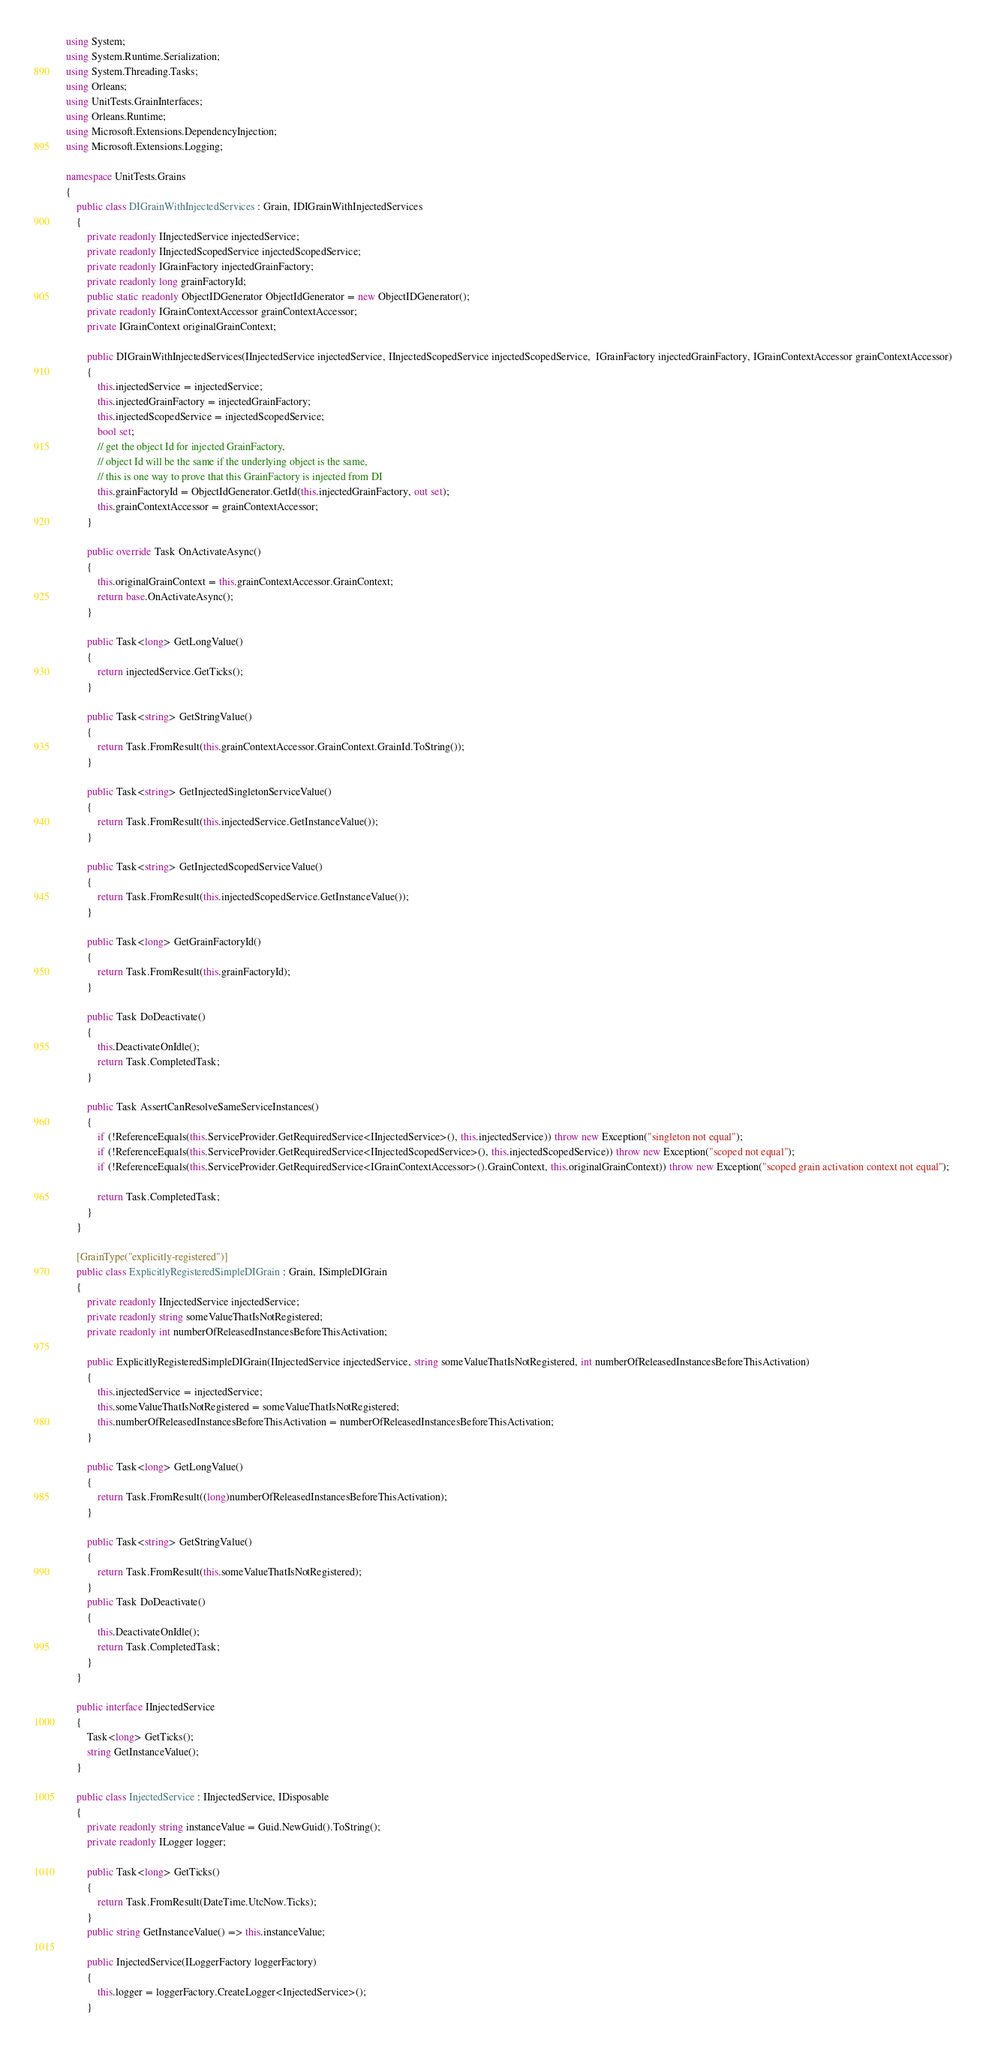<code> <loc_0><loc_0><loc_500><loc_500><_C#_>using System;
using System.Runtime.Serialization;
using System.Threading.Tasks;
using Orleans;
using UnitTests.GrainInterfaces;
using Orleans.Runtime;
using Microsoft.Extensions.DependencyInjection;
using Microsoft.Extensions.Logging;

namespace UnitTests.Grains
{
    public class DIGrainWithInjectedServices : Grain, IDIGrainWithInjectedServices
    {
        private readonly IInjectedService injectedService;
        private readonly IInjectedScopedService injectedScopedService;
        private readonly IGrainFactory injectedGrainFactory;
        private readonly long grainFactoryId;
        public static readonly ObjectIDGenerator ObjectIdGenerator = new ObjectIDGenerator();
        private readonly IGrainContextAccessor grainContextAccessor;
        private IGrainContext originalGrainContext;

        public DIGrainWithInjectedServices(IInjectedService injectedService, IInjectedScopedService injectedScopedService,  IGrainFactory injectedGrainFactory, IGrainContextAccessor grainContextAccessor)
        {
            this.injectedService = injectedService;
            this.injectedGrainFactory = injectedGrainFactory;
            this.injectedScopedService = injectedScopedService;
            bool set;
            // get the object Id for injected GrainFactory, 
            // object Id will be the same if the underlying object is the same,
            // this is one way to prove that this GrainFactory is injected from DI
            this.grainFactoryId = ObjectIdGenerator.GetId(this.injectedGrainFactory, out set);
            this.grainContextAccessor = grainContextAccessor;
        }

        public override Task OnActivateAsync()
        {
            this.originalGrainContext = this.grainContextAccessor.GrainContext;
            return base.OnActivateAsync();
        }

        public Task<long> GetLongValue()
        {
            return injectedService.GetTicks();
        }

        public Task<string> GetStringValue()
        {
            return Task.FromResult(this.grainContextAccessor.GrainContext.GrainId.ToString());
        }

        public Task<string> GetInjectedSingletonServiceValue()
        {
            return Task.FromResult(this.injectedService.GetInstanceValue());
        }

        public Task<string> GetInjectedScopedServiceValue()
        {
            return Task.FromResult(this.injectedScopedService.GetInstanceValue());
        }

        public Task<long> GetGrainFactoryId()
        {
            return Task.FromResult(this.grainFactoryId);
        }

        public Task DoDeactivate()
        {
            this.DeactivateOnIdle();
            return Task.CompletedTask;
        }

        public Task AssertCanResolveSameServiceInstances()
        {
            if (!ReferenceEquals(this.ServiceProvider.GetRequiredService<IInjectedService>(), this.injectedService)) throw new Exception("singleton not equal");
            if (!ReferenceEquals(this.ServiceProvider.GetRequiredService<IInjectedScopedService>(), this.injectedScopedService)) throw new Exception("scoped not equal");
            if (!ReferenceEquals(this.ServiceProvider.GetRequiredService<IGrainContextAccessor>().GrainContext, this.originalGrainContext)) throw new Exception("scoped grain activation context not equal");

            return Task.CompletedTask;
        }
    }

    [GrainType("explicitly-registered")]
    public class ExplicitlyRegisteredSimpleDIGrain : Grain, ISimpleDIGrain
    {
        private readonly IInjectedService injectedService;
        private readonly string someValueThatIsNotRegistered;
        private readonly int numberOfReleasedInstancesBeforeThisActivation;

        public ExplicitlyRegisteredSimpleDIGrain(IInjectedService injectedService, string someValueThatIsNotRegistered, int numberOfReleasedInstancesBeforeThisActivation)
        {
            this.injectedService = injectedService;
            this.someValueThatIsNotRegistered = someValueThatIsNotRegistered;
            this.numberOfReleasedInstancesBeforeThisActivation = numberOfReleasedInstancesBeforeThisActivation;
        }

        public Task<long> GetLongValue()
        {
            return Task.FromResult((long)numberOfReleasedInstancesBeforeThisActivation);
        }

        public Task<string> GetStringValue()
        {
            return Task.FromResult(this.someValueThatIsNotRegistered);
        }
        public Task DoDeactivate()
        {
            this.DeactivateOnIdle();
            return Task.CompletedTask;
        }
    }

    public interface IInjectedService
    {
        Task<long> GetTicks();
        string GetInstanceValue();
    }

    public class InjectedService : IInjectedService, IDisposable
    {
        private readonly string instanceValue = Guid.NewGuid().ToString();
        private readonly ILogger logger;

        public Task<long> GetTicks()
        {
            return Task.FromResult(DateTime.UtcNow.Ticks);
        }
        public string GetInstanceValue() => this.instanceValue;

        public InjectedService(ILoggerFactory loggerFactory)
        {
            this.logger = loggerFactory.CreateLogger<InjectedService>();
        }
</code> 